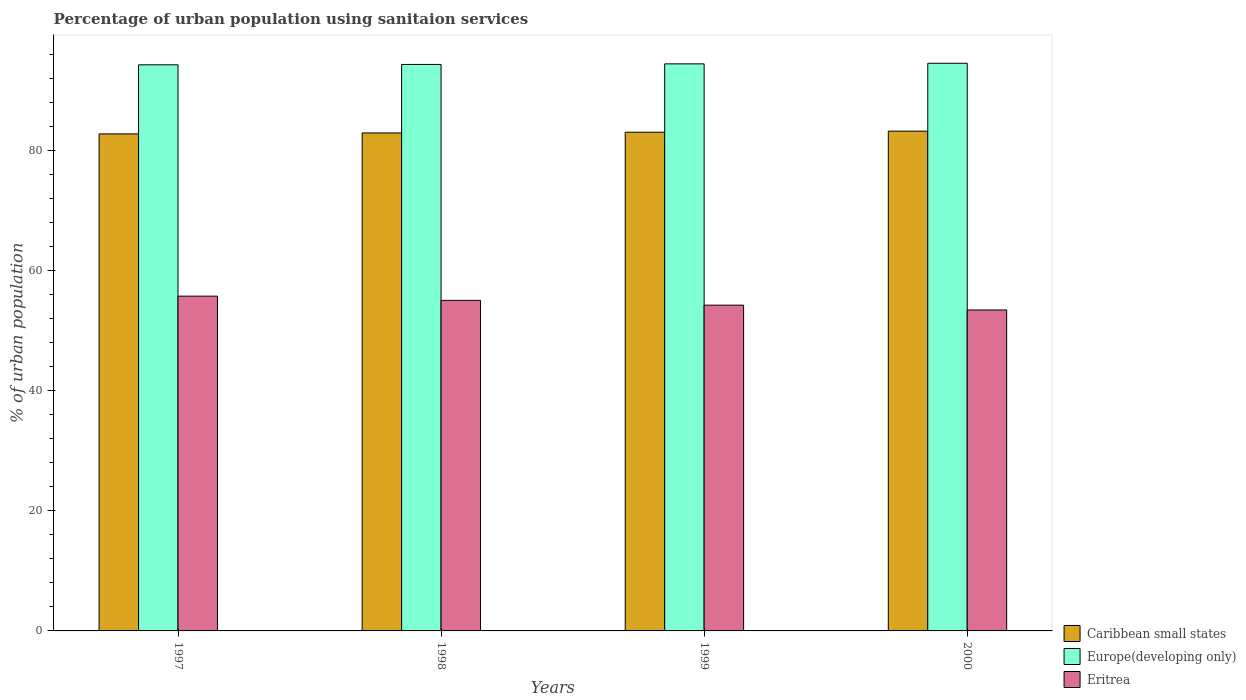How many different coloured bars are there?
Keep it short and to the point. 3. How many groups of bars are there?
Your answer should be very brief. 4. Are the number of bars per tick equal to the number of legend labels?
Provide a succinct answer. Yes. How many bars are there on the 2nd tick from the left?
Offer a terse response. 3. How many bars are there on the 3rd tick from the right?
Give a very brief answer. 3. What is the percentage of urban population using sanitaion services in Caribbean small states in 1997?
Give a very brief answer. 82.84. Across all years, what is the maximum percentage of urban population using sanitaion services in Europe(developing only)?
Your answer should be very brief. 94.62. Across all years, what is the minimum percentage of urban population using sanitaion services in Caribbean small states?
Provide a succinct answer. 82.84. In which year was the percentage of urban population using sanitaion services in Caribbean small states minimum?
Your response must be concise. 1997. What is the total percentage of urban population using sanitaion services in Europe(developing only) in the graph?
Ensure brevity in your answer.  377.92. What is the difference between the percentage of urban population using sanitaion services in Europe(developing only) in 1998 and that in 2000?
Offer a terse response. -0.2. What is the difference between the percentage of urban population using sanitaion services in Caribbean small states in 2000 and the percentage of urban population using sanitaion services in Eritrea in 1998?
Make the answer very short. 28.21. What is the average percentage of urban population using sanitaion services in Eritrea per year?
Provide a succinct answer. 54.67. In the year 1998, what is the difference between the percentage of urban population using sanitaion services in Eritrea and percentage of urban population using sanitaion services in Caribbean small states?
Ensure brevity in your answer.  -27.9. In how many years, is the percentage of urban population using sanitaion services in Europe(developing only) greater than 80 %?
Make the answer very short. 4. What is the ratio of the percentage of urban population using sanitaion services in Europe(developing only) in 1998 to that in 1999?
Offer a very short reply. 1. Is the percentage of urban population using sanitaion services in Caribbean small states in 1997 less than that in 1998?
Offer a terse response. Yes. What is the difference between the highest and the second highest percentage of urban population using sanitaion services in Caribbean small states?
Offer a very short reply. 0.18. What is the difference between the highest and the lowest percentage of urban population using sanitaion services in Caribbean small states?
Make the answer very short. 0.47. What does the 1st bar from the left in 1997 represents?
Keep it short and to the point. Caribbean small states. What does the 1st bar from the right in 2000 represents?
Give a very brief answer. Eritrea. How many years are there in the graph?
Offer a terse response. 4. What is the difference between two consecutive major ticks on the Y-axis?
Provide a succinct answer. 20. Are the values on the major ticks of Y-axis written in scientific E-notation?
Keep it short and to the point. No. How many legend labels are there?
Keep it short and to the point. 3. What is the title of the graph?
Offer a very short reply. Percentage of urban population using sanitaion services. Does "Zimbabwe" appear as one of the legend labels in the graph?
Your answer should be compact. No. What is the label or title of the Y-axis?
Your response must be concise. % of urban population. What is the % of urban population in Caribbean small states in 1997?
Make the answer very short. 82.84. What is the % of urban population of Europe(developing only) in 1997?
Ensure brevity in your answer.  94.36. What is the % of urban population of Eritrea in 1997?
Offer a terse response. 55.8. What is the % of urban population of Caribbean small states in 1998?
Offer a very short reply. 83. What is the % of urban population in Europe(developing only) in 1998?
Make the answer very short. 94.42. What is the % of urban population of Eritrea in 1998?
Provide a succinct answer. 55.1. What is the % of urban population in Caribbean small states in 1999?
Provide a succinct answer. 83.12. What is the % of urban population in Europe(developing only) in 1999?
Your answer should be very brief. 94.52. What is the % of urban population of Eritrea in 1999?
Your answer should be compact. 54.3. What is the % of urban population in Caribbean small states in 2000?
Ensure brevity in your answer.  83.31. What is the % of urban population of Europe(developing only) in 2000?
Keep it short and to the point. 94.62. What is the % of urban population in Eritrea in 2000?
Your answer should be compact. 53.5. Across all years, what is the maximum % of urban population in Caribbean small states?
Provide a succinct answer. 83.31. Across all years, what is the maximum % of urban population in Europe(developing only)?
Keep it short and to the point. 94.62. Across all years, what is the maximum % of urban population in Eritrea?
Offer a very short reply. 55.8. Across all years, what is the minimum % of urban population of Caribbean small states?
Give a very brief answer. 82.84. Across all years, what is the minimum % of urban population in Europe(developing only)?
Your response must be concise. 94.36. Across all years, what is the minimum % of urban population of Eritrea?
Offer a terse response. 53.5. What is the total % of urban population of Caribbean small states in the graph?
Provide a short and direct response. 332.28. What is the total % of urban population in Europe(developing only) in the graph?
Offer a terse response. 377.92. What is the total % of urban population in Eritrea in the graph?
Provide a short and direct response. 218.7. What is the difference between the % of urban population of Caribbean small states in 1997 and that in 1998?
Keep it short and to the point. -0.16. What is the difference between the % of urban population of Europe(developing only) in 1997 and that in 1998?
Keep it short and to the point. -0.06. What is the difference between the % of urban population in Caribbean small states in 1997 and that in 1999?
Your answer should be very brief. -0.28. What is the difference between the % of urban population of Europe(developing only) in 1997 and that in 1999?
Keep it short and to the point. -0.16. What is the difference between the % of urban population of Eritrea in 1997 and that in 1999?
Offer a very short reply. 1.5. What is the difference between the % of urban population in Caribbean small states in 1997 and that in 2000?
Give a very brief answer. -0.47. What is the difference between the % of urban population of Europe(developing only) in 1997 and that in 2000?
Your response must be concise. -0.26. What is the difference between the % of urban population of Eritrea in 1997 and that in 2000?
Give a very brief answer. 2.3. What is the difference between the % of urban population of Caribbean small states in 1998 and that in 1999?
Offer a very short reply. -0.12. What is the difference between the % of urban population in Europe(developing only) in 1998 and that in 1999?
Your response must be concise. -0.1. What is the difference between the % of urban population in Caribbean small states in 1998 and that in 2000?
Offer a very short reply. -0.31. What is the difference between the % of urban population of Europe(developing only) in 1998 and that in 2000?
Provide a short and direct response. -0.2. What is the difference between the % of urban population in Caribbean small states in 1999 and that in 2000?
Provide a succinct answer. -0.18. What is the difference between the % of urban population in Europe(developing only) in 1999 and that in 2000?
Your answer should be compact. -0.1. What is the difference between the % of urban population in Caribbean small states in 1997 and the % of urban population in Europe(developing only) in 1998?
Your response must be concise. -11.58. What is the difference between the % of urban population in Caribbean small states in 1997 and the % of urban population in Eritrea in 1998?
Keep it short and to the point. 27.74. What is the difference between the % of urban population in Europe(developing only) in 1997 and the % of urban population in Eritrea in 1998?
Your response must be concise. 39.26. What is the difference between the % of urban population of Caribbean small states in 1997 and the % of urban population of Europe(developing only) in 1999?
Your response must be concise. -11.68. What is the difference between the % of urban population in Caribbean small states in 1997 and the % of urban population in Eritrea in 1999?
Provide a short and direct response. 28.54. What is the difference between the % of urban population of Europe(developing only) in 1997 and the % of urban population of Eritrea in 1999?
Your response must be concise. 40.06. What is the difference between the % of urban population of Caribbean small states in 1997 and the % of urban population of Europe(developing only) in 2000?
Provide a short and direct response. -11.78. What is the difference between the % of urban population in Caribbean small states in 1997 and the % of urban population in Eritrea in 2000?
Give a very brief answer. 29.34. What is the difference between the % of urban population of Europe(developing only) in 1997 and the % of urban population of Eritrea in 2000?
Keep it short and to the point. 40.86. What is the difference between the % of urban population of Caribbean small states in 1998 and the % of urban population of Europe(developing only) in 1999?
Give a very brief answer. -11.52. What is the difference between the % of urban population of Caribbean small states in 1998 and the % of urban population of Eritrea in 1999?
Your answer should be very brief. 28.7. What is the difference between the % of urban population of Europe(developing only) in 1998 and the % of urban population of Eritrea in 1999?
Your response must be concise. 40.12. What is the difference between the % of urban population of Caribbean small states in 1998 and the % of urban population of Europe(developing only) in 2000?
Offer a terse response. -11.62. What is the difference between the % of urban population in Caribbean small states in 1998 and the % of urban population in Eritrea in 2000?
Provide a short and direct response. 29.5. What is the difference between the % of urban population in Europe(developing only) in 1998 and the % of urban population in Eritrea in 2000?
Give a very brief answer. 40.92. What is the difference between the % of urban population of Caribbean small states in 1999 and the % of urban population of Europe(developing only) in 2000?
Your answer should be very brief. -11.5. What is the difference between the % of urban population of Caribbean small states in 1999 and the % of urban population of Eritrea in 2000?
Provide a short and direct response. 29.62. What is the difference between the % of urban population of Europe(developing only) in 1999 and the % of urban population of Eritrea in 2000?
Offer a very short reply. 41.02. What is the average % of urban population of Caribbean small states per year?
Keep it short and to the point. 83.07. What is the average % of urban population in Europe(developing only) per year?
Your answer should be very brief. 94.48. What is the average % of urban population in Eritrea per year?
Your answer should be very brief. 54.67. In the year 1997, what is the difference between the % of urban population of Caribbean small states and % of urban population of Europe(developing only)?
Give a very brief answer. -11.52. In the year 1997, what is the difference between the % of urban population in Caribbean small states and % of urban population in Eritrea?
Keep it short and to the point. 27.04. In the year 1997, what is the difference between the % of urban population of Europe(developing only) and % of urban population of Eritrea?
Keep it short and to the point. 38.56. In the year 1998, what is the difference between the % of urban population in Caribbean small states and % of urban population in Europe(developing only)?
Your answer should be very brief. -11.42. In the year 1998, what is the difference between the % of urban population in Caribbean small states and % of urban population in Eritrea?
Your response must be concise. 27.9. In the year 1998, what is the difference between the % of urban population in Europe(developing only) and % of urban population in Eritrea?
Ensure brevity in your answer.  39.32. In the year 1999, what is the difference between the % of urban population in Caribbean small states and % of urban population in Europe(developing only)?
Keep it short and to the point. -11.39. In the year 1999, what is the difference between the % of urban population of Caribbean small states and % of urban population of Eritrea?
Provide a short and direct response. 28.82. In the year 1999, what is the difference between the % of urban population of Europe(developing only) and % of urban population of Eritrea?
Give a very brief answer. 40.22. In the year 2000, what is the difference between the % of urban population of Caribbean small states and % of urban population of Europe(developing only)?
Give a very brief answer. -11.31. In the year 2000, what is the difference between the % of urban population of Caribbean small states and % of urban population of Eritrea?
Provide a short and direct response. 29.81. In the year 2000, what is the difference between the % of urban population in Europe(developing only) and % of urban population in Eritrea?
Ensure brevity in your answer.  41.12. What is the ratio of the % of urban population in Caribbean small states in 1997 to that in 1998?
Give a very brief answer. 1. What is the ratio of the % of urban population in Europe(developing only) in 1997 to that in 1998?
Make the answer very short. 1. What is the ratio of the % of urban population in Eritrea in 1997 to that in 1998?
Keep it short and to the point. 1.01. What is the ratio of the % of urban population of Europe(developing only) in 1997 to that in 1999?
Your answer should be very brief. 1. What is the ratio of the % of urban population in Eritrea in 1997 to that in 1999?
Make the answer very short. 1.03. What is the ratio of the % of urban population in Caribbean small states in 1997 to that in 2000?
Offer a terse response. 0.99. What is the ratio of the % of urban population in Eritrea in 1997 to that in 2000?
Offer a very short reply. 1.04. What is the ratio of the % of urban population in Europe(developing only) in 1998 to that in 1999?
Make the answer very short. 1. What is the ratio of the % of urban population in Eritrea in 1998 to that in 1999?
Your answer should be compact. 1.01. What is the ratio of the % of urban population of Caribbean small states in 1998 to that in 2000?
Your answer should be compact. 1. What is the ratio of the % of urban population in Europe(developing only) in 1998 to that in 2000?
Give a very brief answer. 1. What is the ratio of the % of urban population of Eritrea in 1998 to that in 2000?
Give a very brief answer. 1.03. What is the ratio of the % of urban population of Europe(developing only) in 1999 to that in 2000?
Keep it short and to the point. 1. What is the ratio of the % of urban population in Eritrea in 1999 to that in 2000?
Your response must be concise. 1.01. What is the difference between the highest and the second highest % of urban population in Caribbean small states?
Ensure brevity in your answer.  0.18. What is the difference between the highest and the second highest % of urban population in Europe(developing only)?
Provide a succinct answer. 0.1. What is the difference between the highest and the second highest % of urban population in Eritrea?
Provide a short and direct response. 0.7. What is the difference between the highest and the lowest % of urban population of Caribbean small states?
Keep it short and to the point. 0.47. What is the difference between the highest and the lowest % of urban population of Europe(developing only)?
Your answer should be compact. 0.26. What is the difference between the highest and the lowest % of urban population in Eritrea?
Offer a very short reply. 2.3. 